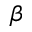Convert formula to latex. <formula><loc_0><loc_0><loc_500><loc_500>\beta</formula> 